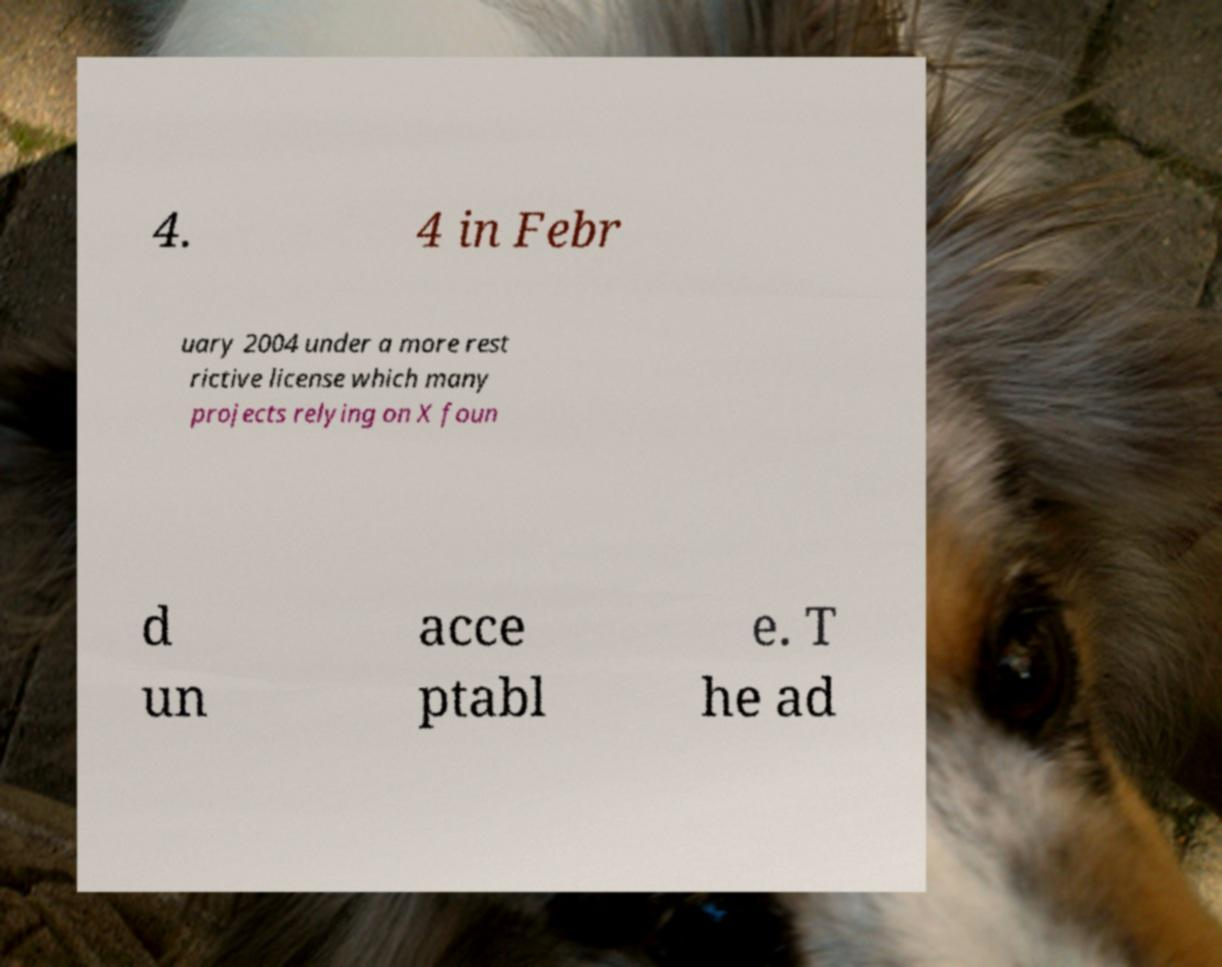Could you extract and type out the text from this image? 4. 4 in Febr uary 2004 under a more rest rictive license which many projects relying on X foun d un acce ptabl e. T he ad 